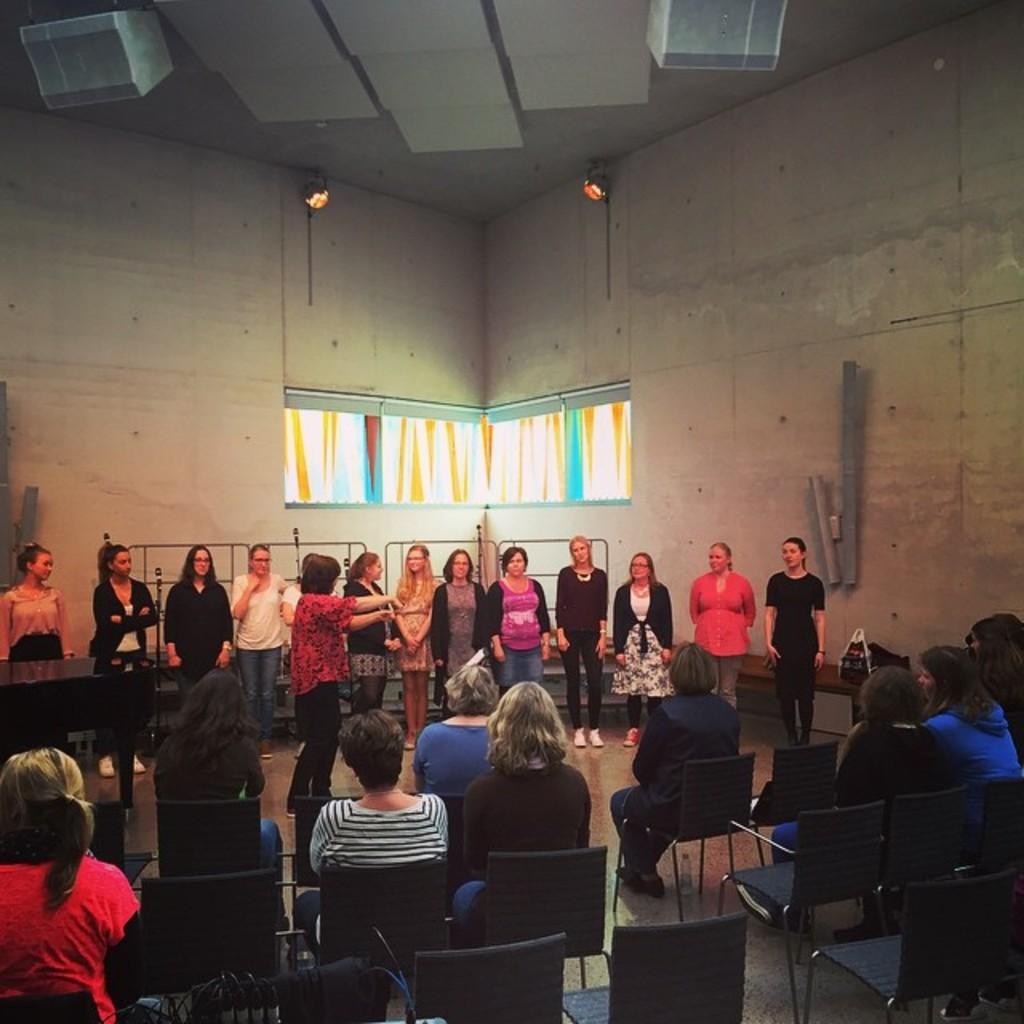Describe this image in one or two sentences. In this image, we can see some people standing, there are some people sitting on the chairs, we can see the walls and windows, at the top we can see two speakers. 